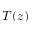<formula> <loc_0><loc_0><loc_500><loc_500>T ( z )</formula> 